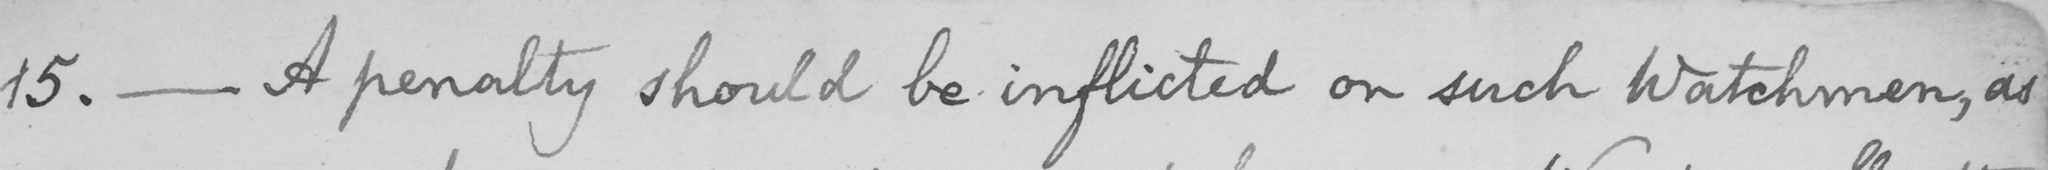Can you tell me what this handwritten text says? 15 .  _  A penalty should be inflicted on such Watchmen , as 